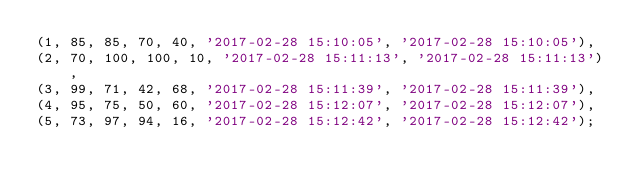<code> <loc_0><loc_0><loc_500><loc_500><_SQL_>(1, 85, 85, 70, 40, '2017-02-28 15:10:05', '2017-02-28 15:10:05'),
(2, 70, 100, 100, 10, '2017-02-28 15:11:13', '2017-02-28 15:11:13'),
(3, 99, 71, 42, 68, '2017-02-28 15:11:39', '2017-02-28 15:11:39'),
(4, 95, 75, 50, 60, '2017-02-28 15:12:07', '2017-02-28 15:12:07'),
(5, 73, 97, 94, 16, '2017-02-28 15:12:42', '2017-02-28 15:12:42');

</code> 